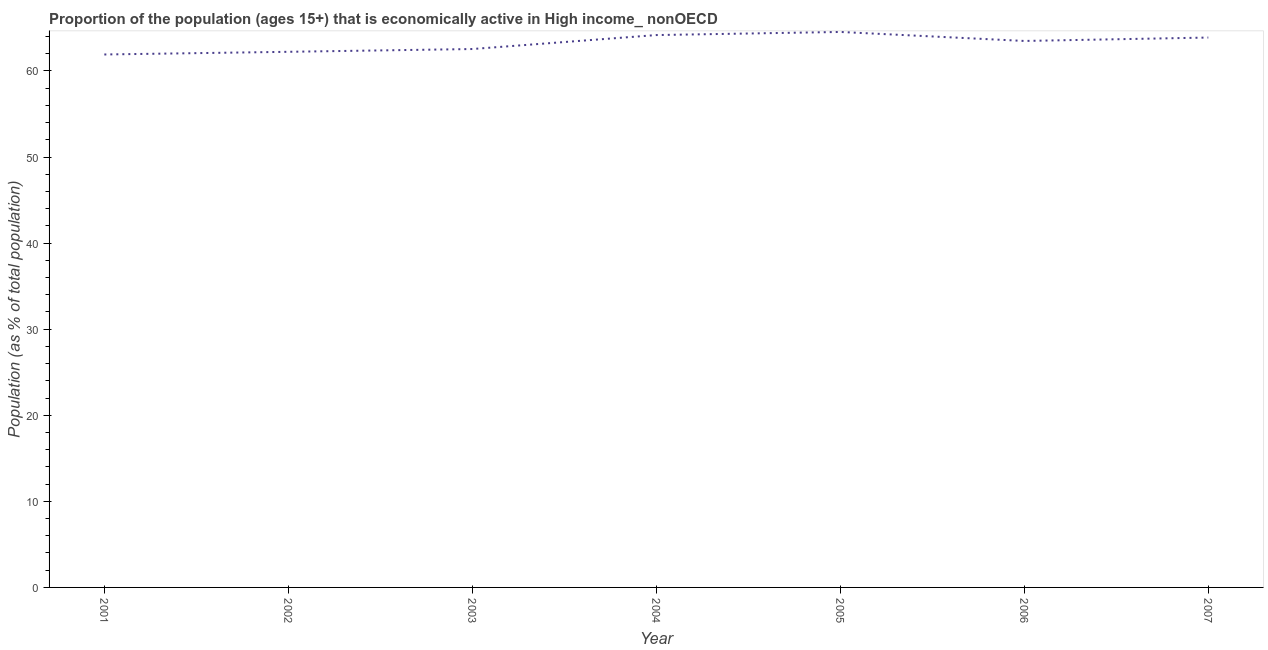What is the percentage of economically active population in 2004?
Provide a succinct answer. 64.17. Across all years, what is the maximum percentage of economically active population?
Provide a succinct answer. 64.53. Across all years, what is the minimum percentage of economically active population?
Your response must be concise. 61.92. In which year was the percentage of economically active population maximum?
Your response must be concise. 2005. What is the sum of the percentage of economically active population?
Your answer should be compact. 442.78. What is the difference between the percentage of economically active population in 2005 and 2007?
Provide a short and direct response. 0.65. What is the average percentage of economically active population per year?
Your answer should be compact. 63.25. What is the median percentage of economically active population?
Make the answer very short. 63.49. In how many years, is the percentage of economically active population greater than 20 %?
Your answer should be compact. 7. What is the ratio of the percentage of economically active population in 2001 to that in 2004?
Your answer should be very brief. 0.96. Is the percentage of economically active population in 2001 less than that in 2003?
Ensure brevity in your answer.  Yes. What is the difference between the highest and the second highest percentage of economically active population?
Your answer should be compact. 0.36. Is the sum of the percentage of economically active population in 2001 and 2006 greater than the maximum percentage of economically active population across all years?
Keep it short and to the point. Yes. What is the difference between the highest and the lowest percentage of economically active population?
Make the answer very short. 2.62. How many lines are there?
Your response must be concise. 1. What is the difference between two consecutive major ticks on the Y-axis?
Your answer should be compact. 10. Are the values on the major ticks of Y-axis written in scientific E-notation?
Provide a succinct answer. No. Does the graph contain any zero values?
Ensure brevity in your answer.  No. What is the title of the graph?
Give a very brief answer. Proportion of the population (ages 15+) that is economically active in High income_ nonOECD. What is the label or title of the Y-axis?
Keep it short and to the point. Population (as % of total population). What is the Population (as % of total population) in 2001?
Ensure brevity in your answer.  61.92. What is the Population (as % of total population) in 2002?
Offer a very short reply. 62.23. What is the Population (as % of total population) in 2003?
Your response must be concise. 62.55. What is the Population (as % of total population) in 2004?
Offer a terse response. 64.17. What is the Population (as % of total population) in 2005?
Your answer should be very brief. 64.53. What is the Population (as % of total population) of 2006?
Your response must be concise. 63.49. What is the Population (as % of total population) in 2007?
Give a very brief answer. 63.88. What is the difference between the Population (as % of total population) in 2001 and 2002?
Give a very brief answer. -0.31. What is the difference between the Population (as % of total population) in 2001 and 2003?
Give a very brief answer. -0.63. What is the difference between the Population (as % of total population) in 2001 and 2004?
Keep it short and to the point. -2.26. What is the difference between the Population (as % of total population) in 2001 and 2005?
Make the answer very short. -2.62. What is the difference between the Population (as % of total population) in 2001 and 2006?
Ensure brevity in your answer.  -1.57. What is the difference between the Population (as % of total population) in 2001 and 2007?
Ensure brevity in your answer.  -1.97. What is the difference between the Population (as % of total population) in 2002 and 2003?
Keep it short and to the point. -0.32. What is the difference between the Population (as % of total population) in 2002 and 2004?
Make the answer very short. -1.95. What is the difference between the Population (as % of total population) in 2002 and 2005?
Offer a terse response. -2.31. What is the difference between the Population (as % of total population) in 2002 and 2006?
Ensure brevity in your answer.  -1.26. What is the difference between the Population (as % of total population) in 2002 and 2007?
Your response must be concise. -1.66. What is the difference between the Population (as % of total population) in 2003 and 2004?
Keep it short and to the point. -1.62. What is the difference between the Population (as % of total population) in 2003 and 2005?
Keep it short and to the point. -1.98. What is the difference between the Population (as % of total population) in 2003 and 2006?
Offer a terse response. -0.94. What is the difference between the Population (as % of total population) in 2003 and 2007?
Keep it short and to the point. -1.33. What is the difference between the Population (as % of total population) in 2004 and 2005?
Offer a very short reply. -0.36. What is the difference between the Population (as % of total population) in 2004 and 2006?
Provide a succinct answer. 0.68. What is the difference between the Population (as % of total population) in 2004 and 2007?
Keep it short and to the point. 0.29. What is the difference between the Population (as % of total population) in 2005 and 2006?
Your response must be concise. 1.05. What is the difference between the Population (as % of total population) in 2005 and 2007?
Ensure brevity in your answer.  0.65. What is the difference between the Population (as % of total population) in 2006 and 2007?
Your answer should be very brief. -0.4. What is the ratio of the Population (as % of total population) in 2001 to that in 2003?
Provide a succinct answer. 0.99. What is the ratio of the Population (as % of total population) in 2001 to that in 2004?
Offer a terse response. 0.96. What is the ratio of the Population (as % of total population) in 2001 to that in 2006?
Your answer should be very brief. 0.97. What is the ratio of the Population (as % of total population) in 2001 to that in 2007?
Give a very brief answer. 0.97. What is the ratio of the Population (as % of total population) in 2002 to that in 2003?
Keep it short and to the point. 0.99. What is the ratio of the Population (as % of total population) in 2002 to that in 2004?
Your response must be concise. 0.97. What is the ratio of the Population (as % of total population) in 2003 to that in 2004?
Offer a very short reply. 0.97. What is the ratio of the Population (as % of total population) in 2003 to that in 2005?
Ensure brevity in your answer.  0.97. What is the ratio of the Population (as % of total population) in 2003 to that in 2006?
Your response must be concise. 0.98. What is the ratio of the Population (as % of total population) in 2003 to that in 2007?
Give a very brief answer. 0.98. What is the ratio of the Population (as % of total population) in 2004 to that in 2005?
Provide a short and direct response. 0.99. What is the ratio of the Population (as % of total population) in 2004 to that in 2006?
Offer a terse response. 1.01. What is the ratio of the Population (as % of total population) in 2004 to that in 2007?
Make the answer very short. 1. What is the ratio of the Population (as % of total population) in 2005 to that in 2007?
Your answer should be compact. 1.01. 